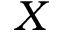Convert formula to latex. <formula><loc_0><loc_0><loc_500><loc_500>X</formula> 